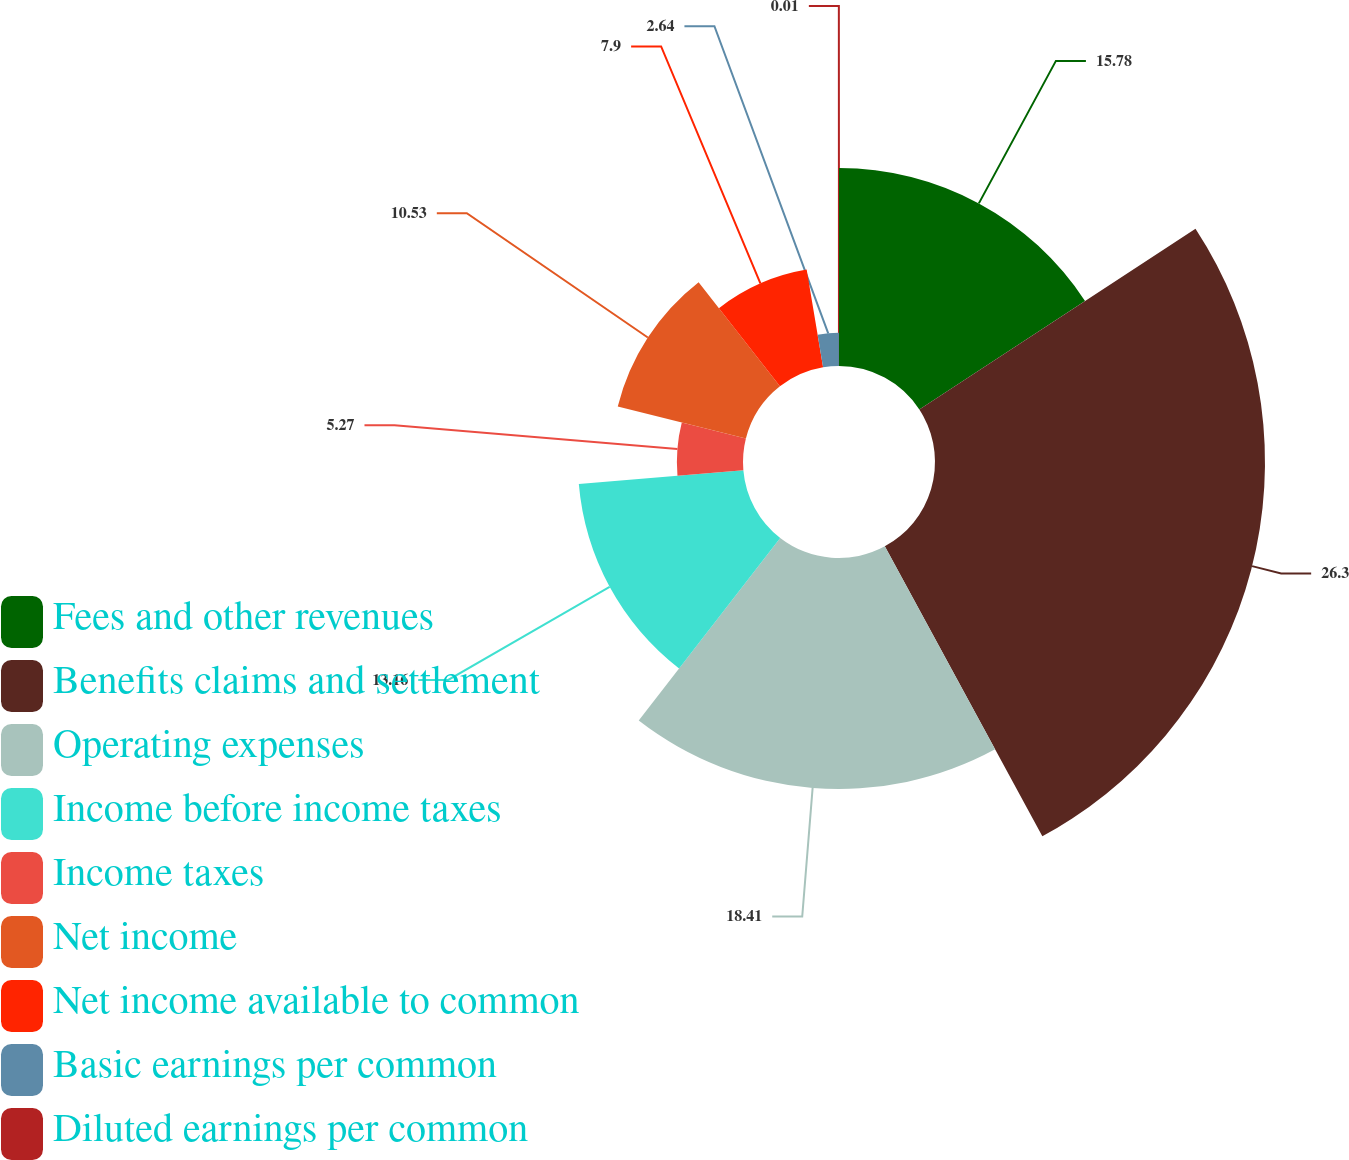<chart> <loc_0><loc_0><loc_500><loc_500><pie_chart><fcel>Fees and other revenues<fcel>Benefits claims and settlement<fcel>Operating expenses<fcel>Income before income taxes<fcel>Income taxes<fcel>Net income<fcel>Net income available to common<fcel>Basic earnings per common<fcel>Diluted earnings per common<nl><fcel>15.78%<fcel>26.3%<fcel>18.41%<fcel>13.16%<fcel>5.27%<fcel>10.53%<fcel>7.9%<fcel>2.64%<fcel>0.01%<nl></chart> 